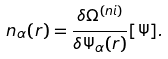<formula> <loc_0><loc_0><loc_500><loc_500>n _ { \alpha } ( r ) = \frac { \delta \Omega ^ { ( n i ) } } { \delta \Psi _ { \alpha } ( r ) } [ \Psi ] .</formula> 